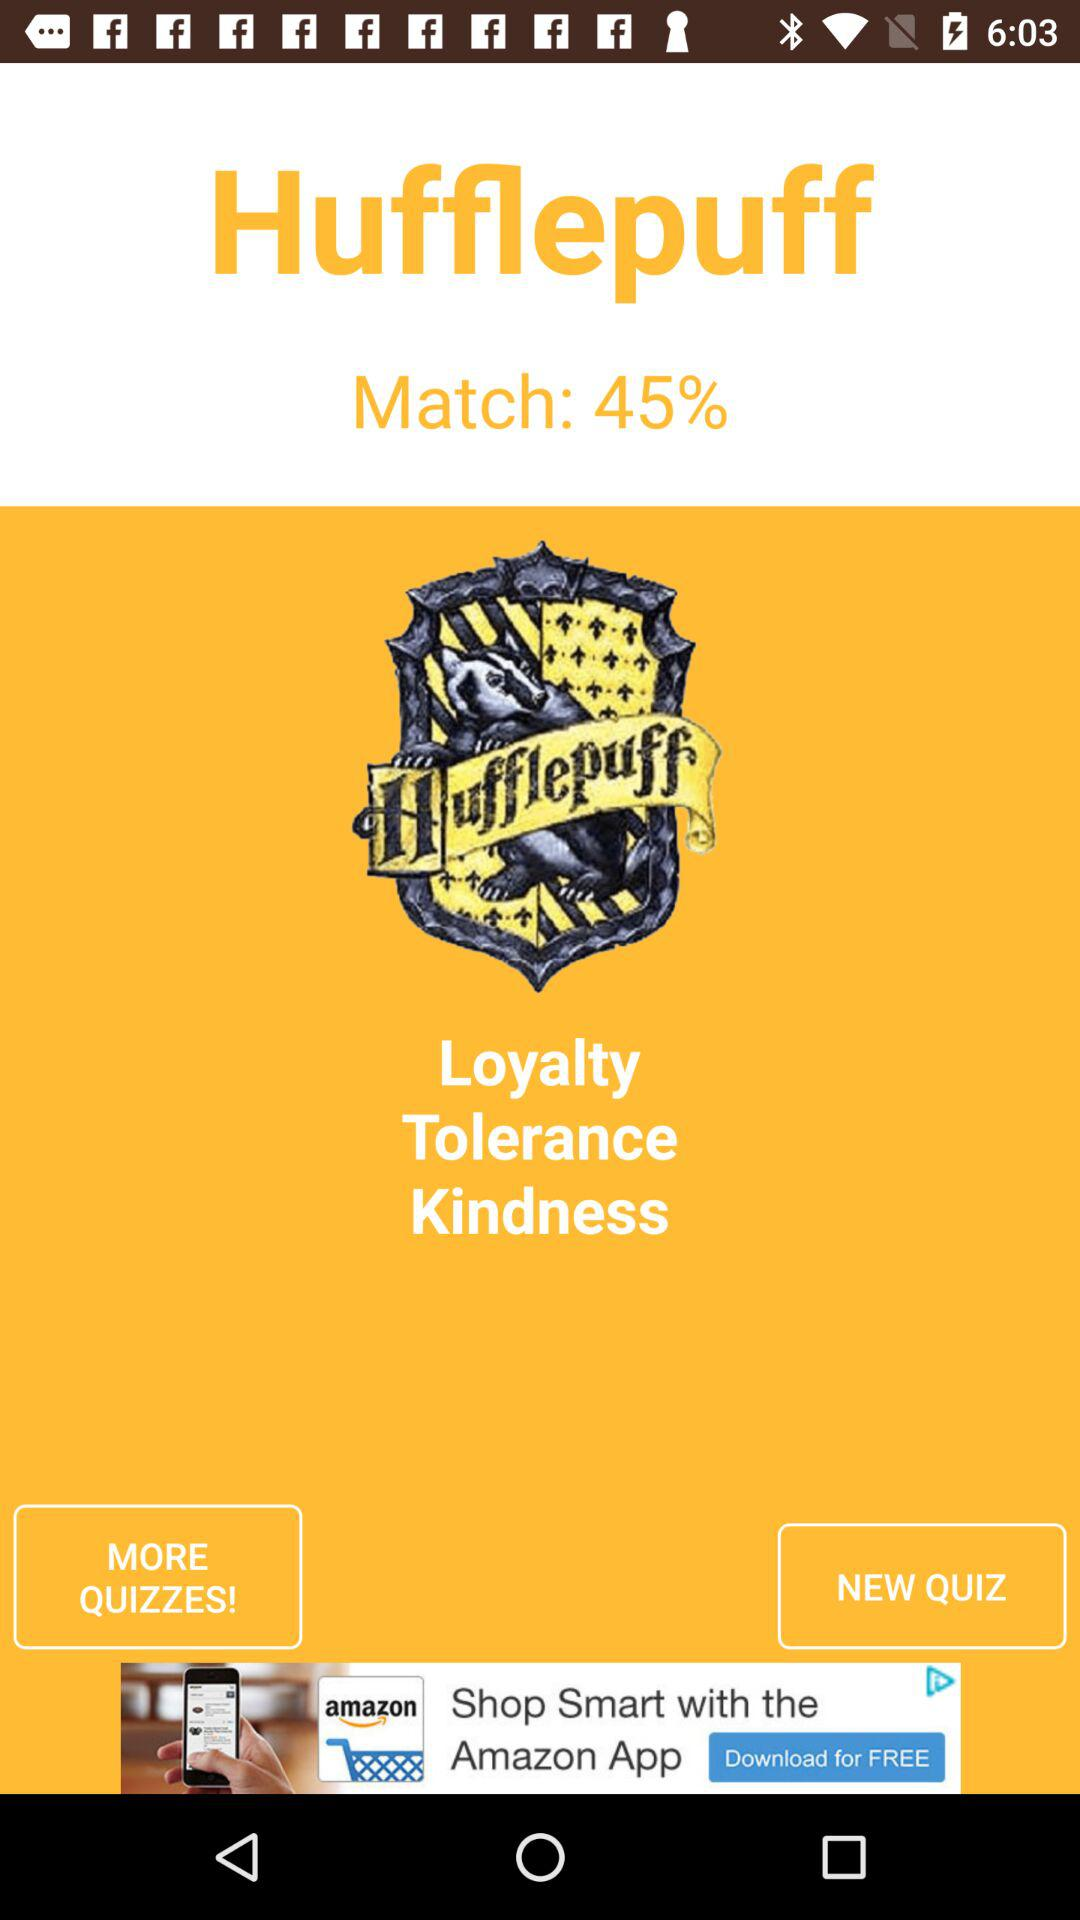What is the name of the application? The name of the application is "Hufflepuff". 